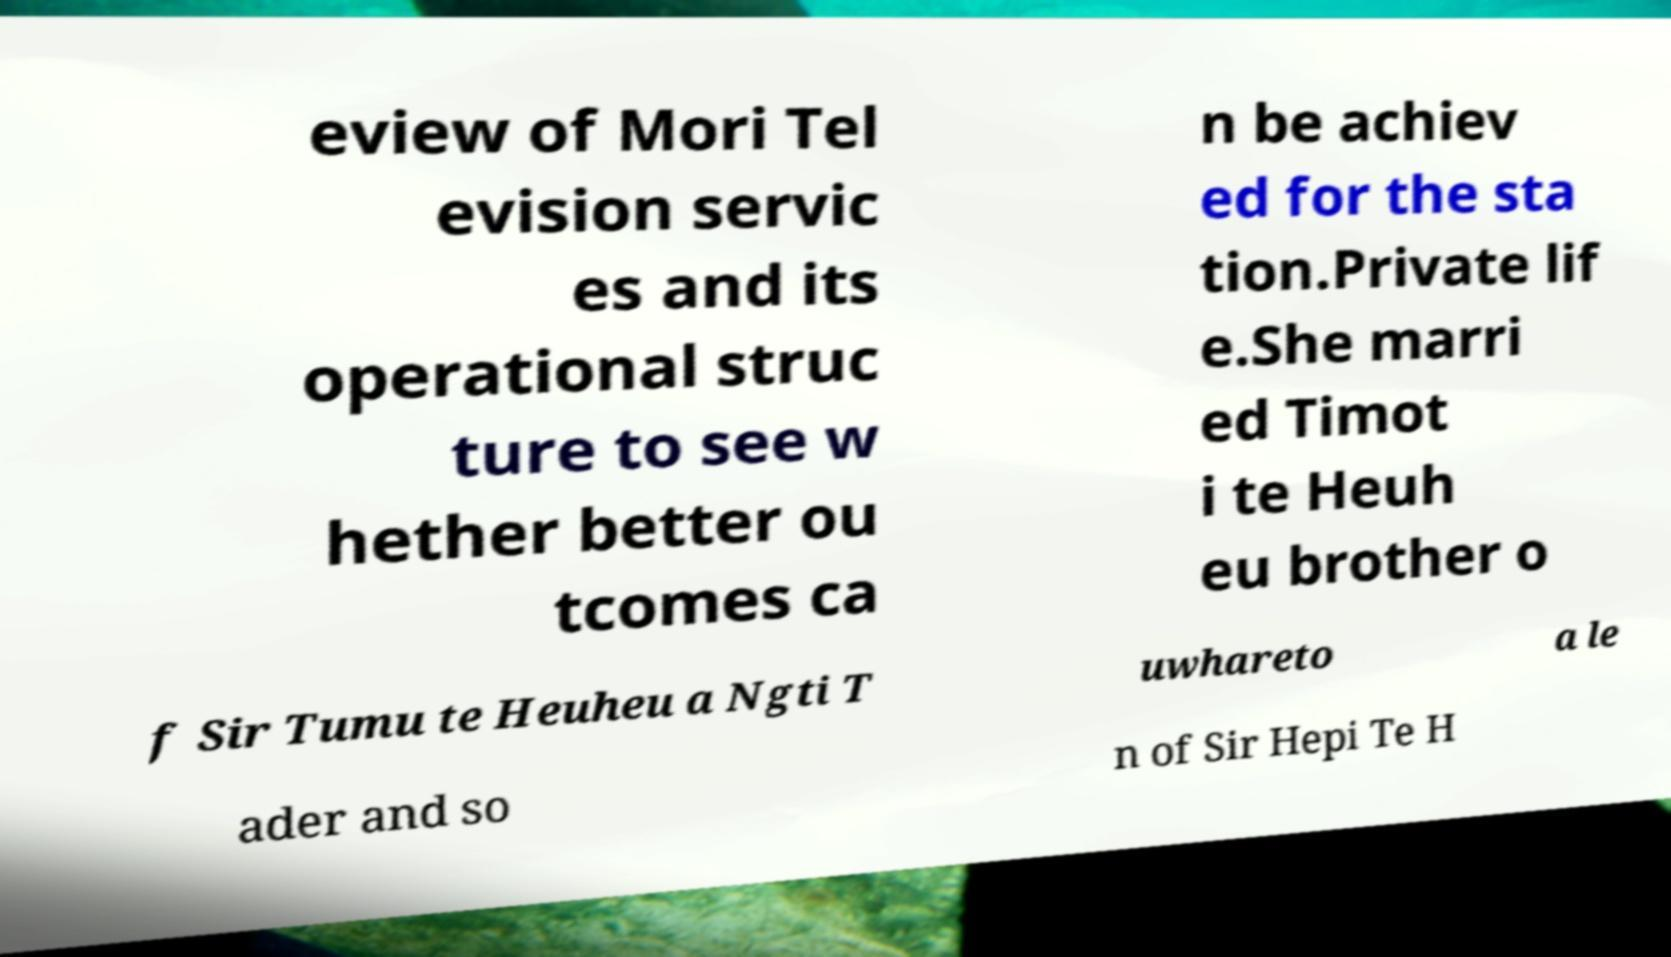Can you accurately transcribe the text from the provided image for me? eview of Mori Tel evision servic es and its operational struc ture to see w hether better ou tcomes ca n be achiev ed for the sta tion.Private lif e.She marri ed Timot i te Heuh eu brother o f Sir Tumu te Heuheu a Ngti T uwhareto a le ader and so n of Sir Hepi Te H 